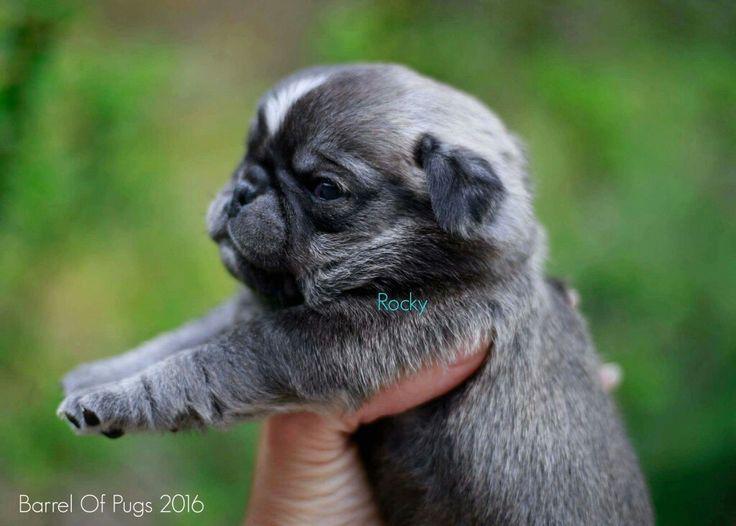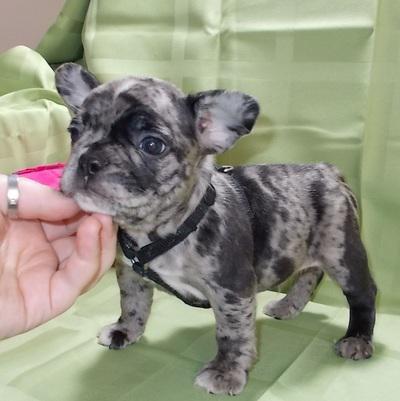The first image is the image on the left, the second image is the image on the right. For the images shown, is this caption "There are at least 3 dogs." true? Answer yes or no. No. The first image is the image on the left, the second image is the image on the right. Considering the images on both sides, is "There are two pups here." valid? Answer yes or no. Yes. 